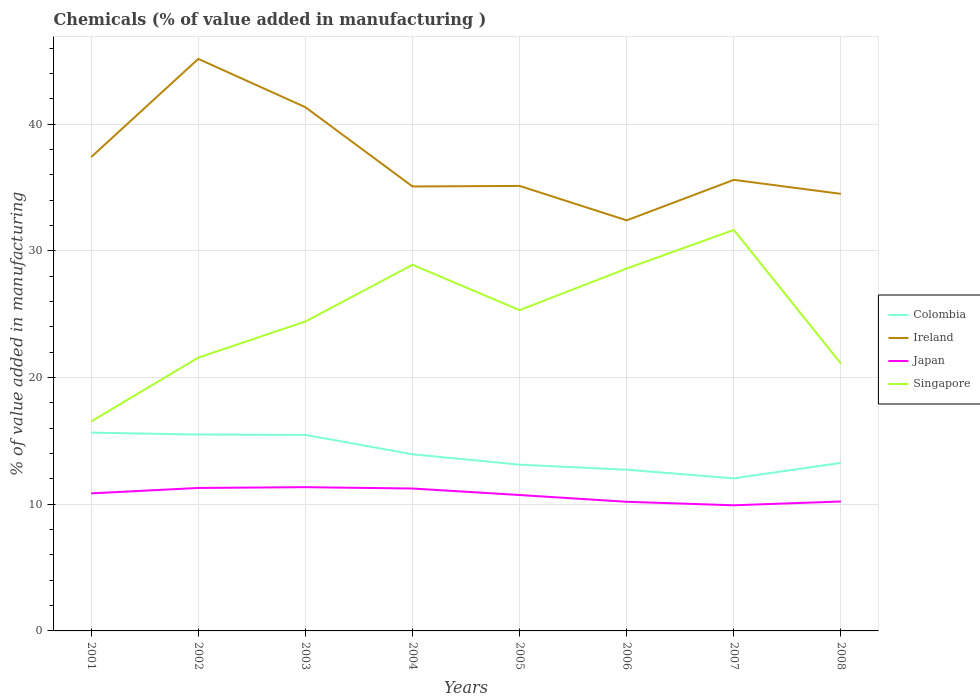Across all years, what is the maximum value added in manufacturing chemicals in Singapore?
Your response must be concise. 16.53. What is the total value added in manufacturing chemicals in Colombia in the graph?
Keep it short and to the point. 2.21. What is the difference between the highest and the second highest value added in manufacturing chemicals in Colombia?
Provide a short and direct response. 3.61. What is the difference between the highest and the lowest value added in manufacturing chemicals in Singapore?
Ensure brevity in your answer.  4. Is the value added in manufacturing chemicals in Singapore strictly greater than the value added in manufacturing chemicals in Japan over the years?
Your answer should be compact. No. How many years are there in the graph?
Your answer should be compact. 8. What is the difference between two consecutive major ticks on the Y-axis?
Your answer should be very brief. 10. Does the graph contain grids?
Offer a terse response. Yes. How many legend labels are there?
Your response must be concise. 4. What is the title of the graph?
Your answer should be compact. Chemicals (% of value added in manufacturing ). Does "Sierra Leone" appear as one of the legend labels in the graph?
Give a very brief answer. No. What is the label or title of the X-axis?
Provide a short and direct response. Years. What is the label or title of the Y-axis?
Provide a short and direct response. % of value added in manufacturing. What is the % of value added in manufacturing in Colombia in 2001?
Keep it short and to the point. 15.65. What is the % of value added in manufacturing in Ireland in 2001?
Provide a short and direct response. 37.4. What is the % of value added in manufacturing in Japan in 2001?
Your answer should be compact. 10.86. What is the % of value added in manufacturing in Singapore in 2001?
Make the answer very short. 16.53. What is the % of value added in manufacturing in Colombia in 2002?
Keep it short and to the point. 15.5. What is the % of value added in manufacturing in Ireland in 2002?
Your answer should be compact. 45.14. What is the % of value added in manufacturing in Japan in 2002?
Your response must be concise. 11.28. What is the % of value added in manufacturing in Singapore in 2002?
Give a very brief answer. 21.57. What is the % of value added in manufacturing in Colombia in 2003?
Offer a terse response. 15.47. What is the % of value added in manufacturing of Ireland in 2003?
Your answer should be very brief. 41.33. What is the % of value added in manufacturing of Japan in 2003?
Keep it short and to the point. 11.34. What is the % of value added in manufacturing in Singapore in 2003?
Your response must be concise. 24.42. What is the % of value added in manufacturing in Colombia in 2004?
Provide a succinct answer. 13.94. What is the % of value added in manufacturing in Ireland in 2004?
Your response must be concise. 35.08. What is the % of value added in manufacturing in Japan in 2004?
Offer a very short reply. 11.24. What is the % of value added in manufacturing in Singapore in 2004?
Your response must be concise. 28.9. What is the % of value added in manufacturing of Colombia in 2005?
Keep it short and to the point. 13.12. What is the % of value added in manufacturing of Ireland in 2005?
Provide a short and direct response. 35.12. What is the % of value added in manufacturing of Japan in 2005?
Provide a succinct answer. 10.73. What is the % of value added in manufacturing of Singapore in 2005?
Keep it short and to the point. 25.32. What is the % of value added in manufacturing in Colombia in 2006?
Your answer should be compact. 12.72. What is the % of value added in manufacturing of Ireland in 2006?
Keep it short and to the point. 32.4. What is the % of value added in manufacturing in Japan in 2006?
Offer a terse response. 10.19. What is the % of value added in manufacturing in Singapore in 2006?
Your answer should be compact. 28.6. What is the % of value added in manufacturing in Colombia in 2007?
Give a very brief answer. 12.04. What is the % of value added in manufacturing of Ireland in 2007?
Offer a terse response. 35.6. What is the % of value added in manufacturing of Japan in 2007?
Make the answer very short. 9.92. What is the % of value added in manufacturing in Singapore in 2007?
Provide a succinct answer. 31.65. What is the % of value added in manufacturing in Colombia in 2008?
Offer a very short reply. 13.26. What is the % of value added in manufacturing of Ireland in 2008?
Ensure brevity in your answer.  34.49. What is the % of value added in manufacturing of Japan in 2008?
Offer a very short reply. 10.21. What is the % of value added in manufacturing in Singapore in 2008?
Provide a short and direct response. 21.1. Across all years, what is the maximum % of value added in manufacturing of Colombia?
Ensure brevity in your answer.  15.65. Across all years, what is the maximum % of value added in manufacturing of Ireland?
Give a very brief answer. 45.14. Across all years, what is the maximum % of value added in manufacturing in Japan?
Give a very brief answer. 11.34. Across all years, what is the maximum % of value added in manufacturing of Singapore?
Make the answer very short. 31.65. Across all years, what is the minimum % of value added in manufacturing in Colombia?
Offer a terse response. 12.04. Across all years, what is the minimum % of value added in manufacturing in Ireland?
Give a very brief answer. 32.4. Across all years, what is the minimum % of value added in manufacturing of Japan?
Provide a short and direct response. 9.92. Across all years, what is the minimum % of value added in manufacturing of Singapore?
Give a very brief answer. 16.53. What is the total % of value added in manufacturing in Colombia in the graph?
Offer a terse response. 111.7. What is the total % of value added in manufacturing in Ireland in the graph?
Your answer should be compact. 296.56. What is the total % of value added in manufacturing in Japan in the graph?
Keep it short and to the point. 85.77. What is the total % of value added in manufacturing in Singapore in the graph?
Your answer should be very brief. 198.08. What is the difference between the % of value added in manufacturing of Colombia in 2001 and that in 2002?
Ensure brevity in your answer.  0.15. What is the difference between the % of value added in manufacturing in Ireland in 2001 and that in 2002?
Offer a terse response. -7.75. What is the difference between the % of value added in manufacturing of Japan in 2001 and that in 2002?
Offer a terse response. -0.43. What is the difference between the % of value added in manufacturing in Singapore in 2001 and that in 2002?
Make the answer very short. -5.04. What is the difference between the % of value added in manufacturing of Colombia in 2001 and that in 2003?
Keep it short and to the point. 0.18. What is the difference between the % of value added in manufacturing of Ireland in 2001 and that in 2003?
Offer a terse response. -3.93. What is the difference between the % of value added in manufacturing of Japan in 2001 and that in 2003?
Your response must be concise. -0.49. What is the difference between the % of value added in manufacturing of Singapore in 2001 and that in 2003?
Ensure brevity in your answer.  -7.88. What is the difference between the % of value added in manufacturing of Colombia in 2001 and that in 2004?
Offer a very short reply. 1.71. What is the difference between the % of value added in manufacturing in Ireland in 2001 and that in 2004?
Offer a very short reply. 2.32. What is the difference between the % of value added in manufacturing of Japan in 2001 and that in 2004?
Provide a short and direct response. -0.38. What is the difference between the % of value added in manufacturing of Singapore in 2001 and that in 2004?
Give a very brief answer. -12.36. What is the difference between the % of value added in manufacturing in Colombia in 2001 and that in 2005?
Keep it short and to the point. 2.53. What is the difference between the % of value added in manufacturing of Ireland in 2001 and that in 2005?
Keep it short and to the point. 2.28. What is the difference between the % of value added in manufacturing in Japan in 2001 and that in 2005?
Keep it short and to the point. 0.13. What is the difference between the % of value added in manufacturing of Singapore in 2001 and that in 2005?
Offer a terse response. -8.78. What is the difference between the % of value added in manufacturing in Colombia in 2001 and that in 2006?
Make the answer very short. 2.93. What is the difference between the % of value added in manufacturing in Ireland in 2001 and that in 2006?
Your answer should be very brief. 5. What is the difference between the % of value added in manufacturing of Japan in 2001 and that in 2006?
Your answer should be very brief. 0.66. What is the difference between the % of value added in manufacturing of Singapore in 2001 and that in 2006?
Offer a very short reply. -12.07. What is the difference between the % of value added in manufacturing in Colombia in 2001 and that in 2007?
Offer a terse response. 3.61. What is the difference between the % of value added in manufacturing in Ireland in 2001 and that in 2007?
Your answer should be compact. 1.8. What is the difference between the % of value added in manufacturing of Japan in 2001 and that in 2007?
Make the answer very short. 0.94. What is the difference between the % of value added in manufacturing in Singapore in 2001 and that in 2007?
Offer a terse response. -15.11. What is the difference between the % of value added in manufacturing in Colombia in 2001 and that in 2008?
Your answer should be compact. 2.39. What is the difference between the % of value added in manufacturing in Ireland in 2001 and that in 2008?
Give a very brief answer. 2.9. What is the difference between the % of value added in manufacturing of Japan in 2001 and that in 2008?
Provide a short and direct response. 0.64. What is the difference between the % of value added in manufacturing in Singapore in 2001 and that in 2008?
Your answer should be compact. -4.57. What is the difference between the % of value added in manufacturing of Colombia in 2002 and that in 2003?
Ensure brevity in your answer.  0.03. What is the difference between the % of value added in manufacturing in Ireland in 2002 and that in 2003?
Offer a very short reply. 3.81. What is the difference between the % of value added in manufacturing in Japan in 2002 and that in 2003?
Your answer should be very brief. -0.06. What is the difference between the % of value added in manufacturing of Singapore in 2002 and that in 2003?
Your answer should be compact. -2.85. What is the difference between the % of value added in manufacturing in Colombia in 2002 and that in 2004?
Your response must be concise. 1.56. What is the difference between the % of value added in manufacturing of Ireland in 2002 and that in 2004?
Keep it short and to the point. 10.07. What is the difference between the % of value added in manufacturing in Japan in 2002 and that in 2004?
Your answer should be compact. 0.04. What is the difference between the % of value added in manufacturing in Singapore in 2002 and that in 2004?
Give a very brief answer. -7.33. What is the difference between the % of value added in manufacturing of Colombia in 2002 and that in 2005?
Give a very brief answer. 2.38. What is the difference between the % of value added in manufacturing in Ireland in 2002 and that in 2005?
Your answer should be compact. 10.03. What is the difference between the % of value added in manufacturing of Japan in 2002 and that in 2005?
Make the answer very short. 0.56. What is the difference between the % of value added in manufacturing in Singapore in 2002 and that in 2005?
Your response must be concise. -3.75. What is the difference between the % of value added in manufacturing of Colombia in 2002 and that in 2006?
Give a very brief answer. 2.78. What is the difference between the % of value added in manufacturing of Ireland in 2002 and that in 2006?
Ensure brevity in your answer.  12.74. What is the difference between the % of value added in manufacturing of Japan in 2002 and that in 2006?
Provide a succinct answer. 1.09. What is the difference between the % of value added in manufacturing in Singapore in 2002 and that in 2006?
Keep it short and to the point. -7.03. What is the difference between the % of value added in manufacturing of Colombia in 2002 and that in 2007?
Provide a succinct answer. 3.46. What is the difference between the % of value added in manufacturing of Ireland in 2002 and that in 2007?
Provide a succinct answer. 9.55. What is the difference between the % of value added in manufacturing in Japan in 2002 and that in 2007?
Offer a very short reply. 1.37. What is the difference between the % of value added in manufacturing of Singapore in 2002 and that in 2007?
Your answer should be very brief. -10.08. What is the difference between the % of value added in manufacturing of Colombia in 2002 and that in 2008?
Ensure brevity in your answer.  2.24. What is the difference between the % of value added in manufacturing of Ireland in 2002 and that in 2008?
Keep it short and to the point. 10.65. What is the difference between the % of value added in manufacturing of Japan in 2002 and that in 2008?
Offer a very short reply. 1.07. What is the difference between the % of value added in manufacturing in Singapore in 2002 and that in 2008?
Your answer should be compact. 0.47. What is the difference between the % of value added in manufacturing of Colombia in 2003 and that in 2004?
Provide a short and direct response. 1.53. What is the difference between the % of value added in manufacturing of Ireland in 2003 and that in 2004?
Make the answer very short. 6.25. What is the difference between the % of value added in manufacturing in Japan in 2003 and that in 2004?
Your answer should be compact. 0.11. What is the difference between the % of value added in manufacturing of Singapore in 2003 and that in 2004?
Ensure brevity in your answer.  -4.48. What is the difference between the % of value added in manufacturing of Colombia in 2003 and that in 2005?
Ensure brevity in your answer.  2.35. What is the difference between the % of value added in manufacturing in Ireland in 2003 and that in 2005?
Your answer should be compact. 6.21. What is the difference between the % of value added in manufacturing of Japan in 2003 and that in 2005?
Offer a very short reply. 0.62. What is the difference between the % of value added in manufacturing of Singapore in 2003 and that in 2005?
Give a very brief answer. -0.9. What is the difference between the % of value added in manufacturing in Colombia in 2003 and that in 2006?
Offer a very short reply. 2.75. What is the difference between the % of value added in manufacturing of Ireland in 2003 and that in 2006?
Provide a short and direct response. 8.93. What is the difference between the % of value added in manufacturing in Japan in 2003 and that in 2006?
Provide a short and direct response. 1.15. What is the difference between the % of value added in manufacturing in Singapore in 2003 and that in 2006?
Provide a succinct answer. -4.18. What is the difference between the % of value added in manufacturing in Colombia in 2003 and that in 2007?
Provide a succinct answer. 3.43. What is the difference between the % of value added in manufacturing of Ireland in 2003 and that in 2007?
Provide a succinct answer. 5.73. What is the difference between the % of value added in manufacturing of Japan in 2003 and that in 2007?
Make the answer very short. 1.43. What is the difference between the % of value added in manufacturing in Singapore in 2003 and that in 2007?
Give a very brief answer. -7.23. What is the difference between the % of value added in manufacturing of Colombia in 2003 and that in 2008?
Give a very brief answer. 2.21. What is the difference between the % of value added in manufacturing of Ireland in 2003 and that in 2008?
Offer a terse response. 6.84. What is the difference between the % of value added in manufacturing of Japan in 2003 and that in 2008?
Your answer should be compact. 1.13. What is the difference between the % of value added in manufacturing of Singapore in 2003 and that in 2008?
Offer a terse response. 3.32. What is the difference between the % of value added in manufacturing of Colombia in 2004 and that in 2005?
Your answer should be very brief. 0.82. What is the difference between the % of value added in manufacturing in Ireland in 2004 and that in 2005?
Give a very brief answer. -0.04. What is the difference between the % of value added in manufacturing of Japan in 2004 and that in 2005?
Your response must be concise. 0.51. What is the difference between the % of value added in manufacturing in Singapore in 2004 and that in 2005?
Provide a short and direct response. 3.58. What is the difference between the % of value added in manufacturing in Colombia in 2004 and that in 2006?
Your response must be concise. 1.22. What is the difference between the % of value added in manufacturing of Ireland in 2004 and that in 2006?
Make the answer very short. 2.67. What is the difference between the % of value added in manufacturing of Japan in 2004 and that in 2006?
Your answer should be compact. 1.05. What is the difference between the % of value added in manufacturing in Singapore in 2004 and that in 2006?
Your answer should be compact. 0.3. What is the difference between the % of value added in manufacturing in Colombia in 2004 and that in 2007?
Your response must be concise. 1.9. What is the difference between the % of value added in manufacturing of Ireland in 2004 and that in 2007?
Your response must be concise. -0.52. What is the difference between the % of value added in manufacturing in Japan in 2004 and that in 2007?
Make the answer very short. 1.32. What is the difference between the % of value added in manufacturing of Singapore in 2004 and that in 2007?
Keep it short and to the point. -2.75. What is the difference between the % of value added in manufacturing in Colombia in 2004 and that in 2008?
Give a very brief answer. 0.68. What is the difference between the % of value added in manufacturing in Ireland in 2004 and that in 2008?
Offer a terse response. 0.58. What is the difference between the % of value added in manufacturing of Japan in 2004 and that in 2008?
Your response must be concise. 1.02. What is the difference between the % of value added in manufacturing of Singapore in 2004 and that in 2008?
Offer a terse response. 7.8. What is the difference between the % of value added in manufacturing in Colombia in 2005 and that in 2006?
Provide a short and direct response. 0.4. What is the difference between the % of value added in manufacturing in Ireland in 2005 and that in 2006?
Ensure brevity in your answer.  2.72. What is the difference between the % of value added in manufacturing of Japan in 2005 and that in 2006?
Ensure brevity in your answer.  0.53. What is the difference between the % of value added in manufacturing of Singapore in 2005 and that in 2006?
Offer a terse response. -3.29. What is the difference between the % of value added in manufacturing in Colombia in 2005 and that in 2007?
Provide a short and direct response. 1.08. What is the difference between the % of value added in manufacturing in Ireland in 2005 and that in 2007?
Your answer should be compact. -0.48. What is the difference between the % of value added in manufacturing in Japan in 2005 and that in 2007?
Offer a very short reply. 0.81. What is the difference between the % of value added in manufacturing of Singapore in 2005 and that in 2007?
Keep it short and to the point. -6.33. What is the difference between the % of value added in manufacturing of Colombia in 2005 and that in 2008?
Provide a short and direct response. -0.14. What is the difference between the % of value added in manufacturing of Ireland in 2005 and that in 2008?
Ensure brevity in your answer.  0.63. What is the difference between the % of value added in manufacturing in Japan in 2005 and that in 2008?
Make the answer very short. 0.51. What is the difference between the % of value added in manufacturing of Singapore in 2005 and that in 2008?
Your response must be concise. 4.22. What is the difference between the % of value added in manufacturing of Colombia in 2006 and that in 2007?
Offer a terse response. 0.68. What is the difference between the % of value added in manufacturing of Ireland in 2006 and that in 2007?
Provide a succinct answer. -3.2. What is the difference between the % of value added in manufacturing in Japan in 2006 and that in 2007?
Provide a short and direct response. 0.28. What is the difference between the % of value added in manufacturing of Singapore in 2006 and that in 2007?
Offer a very short reply. -3.05. What is the difference between the % of value added in manufacturing in Colombia in 2006 and that in 2008?
Your response must be concise. -0.54. What is the difference between the % of value added in manufacturing of Ireland in 2006 and that in 2008?
Provide a short and direct response. -2.09. What is the difference between the % of value added in manufacturing of Japan in 2006 and that in 2008?
Make the answer very short. -0.02. What is the difference between the % of value added in manufacturing of Singapore in 2006 and that in 2008?
Provide a succinct answer. 7.5. What is the difference between the % of value added in manufacturing in Colombia in 2007 and that in 2008?
Your answer should be very brief. -1.22. What is the difference between the % of value added in manufacturing of Ireland in 2007 and that in 2008?
Ensure brevity in your answer.  1.11. What is the difference between the % of value added in manufacturing of Japan in 2007 and that in 2008?
Provide a short and direct response. -0.3. What is the difference between the % of value added in manufacturing in Singapore in 2007 and that in 2008?
Provide a succinct answer. 10.55. What is the difference between the % of value added in manufacturing of Colombia in 2001 and the % of value added in manufacturing of Ireland in 2002?
Keep it short and to the point. -29.5. What is the difference between the % of value added in manufacturing in Colombia in 2001 and the % of value added in manufacturing in Japan in 2002?
Your response must be concise. 4.37. What is the difference between the % of value added in manufacturing in Colombia in 2001 and the % of value added in manufacturing in Singapore in 2002?
Your answer should be compact. -5.92. What is the difference between the % of value added in manufacturing in Ireland in 2001 and the % of value added in manufacturing in Japan in 2002?
Your answer should be compact. 26.12. What is the difference between the % of value added in manufacturing of Ireland in 2001 and the % of value added in manufacturing of Singapore in 2002?
Your answer should be compact. 15.83. What is the difference between the % of value added in manufacturing in Japan in 2001 and the % of value added in manufacturing in Singapore in 2002?
Keep it short and to the point. -10.71. What is the difference between the % of value added in manufacturing of Colombia in 2001 and the % of value added in manufacturing of Ireland in 2003?
Provide a succinct answer. -25.68. What is the difference between the % of value added in manufacturing in Colombia in 2001 and the % of value added in manufacturing in Japan in 2003?
Provide a succinct answer. 4.3. What is the difference between the % of value added in manufacturing in Colombia in 2001 and the % of value added in manufacturing in Singapore in 2003?
Provide a short and direct response. -8.77. What is the difference between the % of value added in manufacturing of Ireland in 2001 and the % of value added in manufacturing of Japan in 2003?
Offer a very short reply. 26.05. What is the difference between the % of value added in manufacturing in Ireland in 2001 and the % of value added in manufacturing in Singapore in 2003?
Ensure brevity in your answer.  12.98. What is the difference between the % of value added in manufacturing of Japan in 2001 and the % of value added in manufacturing of Singapore in 2003?
Offer a very short reply. -13.56. What is the difference between the % of value added in manufacturing in Colombia in 2001 and the % of value added in manufacturing in Ireland in 2004?
Offer a very short reply. -19.43. What is the difference between the % of value added in manufacturing of Colombia in 2001 and the % of value added in manufacturing of Japan in 2004?
Offer a very short reply. 4.41. What is the difference between the % of value added in manufacturing in Colombia in 2001 and the % of value added in manufacturing in Singapore in 2004?
Offer a terse response. -13.25. What is the difference between the % of value added in manufacturing in Ireland in 2001 and the % of value added in manufacturing in Japan in 2004?
Offer a terse response. 26.16. What is the difference between the % of value added in manufacturing of Ireland in 2001 and the % of value added in manufacturing of Singapore in 2004?
Keep it short and to the point. 8.5. What is the difference between the % of value added in manufacturing of Japan in 2001 and the % of value added in manufacturing of Singapore in 2004?
Provide a short and direct response. -18.04. What is the difference between the % of value added in manufacturing of Colombia in 2001 and the % of value added in manufacturing of Ireland in 2005?
Keep it short and to the point. -19.47. What is the difference between the % of value added in manufacturing of Colombia in 2001 and the % of value added in manufacturing of Japan in 2005?
Your answer should be very brief. 4.92. What is the difference between the % of value added in manufacturing in Colombia in 2001 and the % of value added in manufacturing in Singapore in 2005?
Your response must be concise. -9.67. What is the difference between the % of value added in manufacturing of Ireland in 2001 and the % of value added in manufacturing of Japan in 2005?
Make the answer very short. 26.67. What is the difference between the % of value added in manufacturing of Ireland in 2001 and the % of value added in manufacturing of Singapore in 2005?
Your answer should be very brief. 12.08. What is the difference between the % of value added in manufacturing of Japan in 2001 and the % of value added in manufacturing of Singapore in 2005?
Your answer should be very brief. -14.46. What is the difference between the % of value added in manufacturing of Colombia in 2001 and the % of value added in manufacturing of Ireland in 2006?
Offer a terse response. -16.75. What is the difference between the % of value added in manufacturing of Colombia in 2001 and the % of value added in manufacturing of Japan in 2006?
Your answer should be compact. 5.46. What is the difference between the % of value added in manufacturing in Colombia in 2001 and the % of value added in manufacturing in Singapore in 2006?
Ensure brevity in your answer.  -12.95. What is the difference between the % of value added in manufacturing of Ireland in 2001 and the % of value added in manufacturing of Japan in 2006?
Your answer should be very brief. 27.21. What is the difference between the % of value added in manufacturing in Ireland in 2001 and the % of value added in manufacturing in Singapore in 2006?
Your answer should be very brief. 8.8. What is the difference between the % of value added in manufacturing of Japan in 2001 and the % of value added in manufacturing of Singapore in 2006?
Provide a short and direct response. -17.74. What is the difference between the % of value added in manufacturing of Colombia in 2001 and the % of value added in manufacturing of Ireland in 2007?
Give a very brief answer. -19.95. What is the difference between the % of value added in manufacturing of Colombia in 2001 and the % of value added in manufacturing of Japan in 2007?
Your answer should be very brief. 5.73. What is the difference between the % of value added in manufacturing of Colombia in 2001 and the % of value added in manufacturing of Singapore in 2007?
Provide a succinct answer. -16. What is the difference between the % of value added in manufacturing of Ireland in 2001 and the % of value added in manufacturing of Japan in 2007?
Provide a succinct answer. 27.48. What is the difference between the % of value added in manufacturing in Ireland in 2001 and the % of value added in manufacturing in Singapore in 2007?
Your answer should be compact. 5.75. What is the difference between the % of value added in manufacturing of Japan in 2001 and the % of value added in manufacturing of Singapore in 2007?
Your response must be concise. -20.79. What is the difference between the % of value added in manufacturing of Colombia in 2001 and the % of value added in manufacturing of Ireland in 2008?
Give a very brief answer. -18.85. What is the difference between the % of value added in manufacturing in Colombia in 2001 and the % of value added in manufacturing in Japan in 2008?
Offer a very short reply. 5.43. What is the difference between the % of value added in manufacturing in Colombia in 2001 and the % of value added in manufacturing in Singapore in 2008?
Provide a short and direct response. -5.45. What is the difference between the % of value added in manufacturing of Ireland in 2001 and the % of value added in manufacturing of Japan in 2008?
Your answer should be very brief. 27.18. What is the difference between the % of value added in manufacturing in Ireland in 2001 and the % of value added in manufacturing in Singapore in 2008?
Your answer should be very brief. 16.3. What is the difference between the % of value added in manufacturing of Japan in 2001 and the % of value added in manufacturing of Singapore in 2008?
Your response must be concise. -10.24. What is the difference between the % of value added in manufacturing in Colombia in 2002 and the % of value added in manufacturing in Ireland in 2003?
Ensure brevity in your answer.  -25.83. What is the difference between the % of value added in manufacturing of Colombia in 2002 and the % of value added in manufacturing of Japan in 2003?
Make the answer very short. 4.15. What is the difference between the % of value added in manufacturing in Colombia in 2002 and the % of value added in manufacturing in Singapore in 2003?
Give a very brief answer. -8.92. What is the difference between the % of value added in manufacturing in Ireland in 2002 and the % of value added in manufacturing in Japan in 2003?
Make the answer very short. 33.8. What is the difference between the % of value added in manufacturing of Ireland in 2002 and the % of value added in manufacturing of Singapore in 2003?
Keep it short and to the point. 20.73. What is the difference between the % of value added in manufacturing of Japan in 2002 and the % of value added in manufacturing of Singapore in 2003?
Offer a terse response. -13.13. What is the difference between the % of value added in manufacturing in Colombia in 2002 and the % of value added in manufacturing in Ireland in 2004?
Keep it short and to the point. -19.58. What is the difference between the % of value added in manufacturing in Colombia in 2002 and the % of value added in manufacturing in Japan in 2004?
Make the answer very short. 4.26. What is the difference between the % of value added in manufacturing in Colombia in 2002 and the % of value added in manufacturing in Singapore in 2004?
Your answer should be compact. -13.4. What is the difference between the % of value added in manufacturing of Ireland in 2002 and the % of value added in manufacturing of Japan in 2004?
Provide a succinct answer. 33.91. What is the difference between the % of value added in manufacturing of Ireland in 2002 and the % of value added in manufacturing of Singapore in 2004?
Offer a very short reply. 16.25. What is the difference between the % of value added in manufacturing of Japan in 2002 and the % of value added in manufacturing of Singapore in 2004?
Provide a succinct answer. -17.61. What is the difference between the % of value added in manufacturing of Colombia in 2002 and the % of value added in manufacturing of Ireland in 2005?
Make the answer very short. -19.62. What is the difference between the % of value added in manufacturing of Colombia in 2002 and the % of value added in manufacturing of Japan in 2005?
Your answer should be compact. 4.77. What is the difference between the % of value added in manufacturing in Colombia in 2002 and the % of value added in manufacturing in Singapore in 2005?
Provide a short and direct response. -9.82. What is the difference between the % of value added in manufacturing in Ireland in 2002 and the % of value added in manufacturing in Japan in 2005?
Your answer should be very brief. 34.42. What is the difference between the % of value added in manufacturing in Ireland in 2002 and the % of value added in manufacturing in Singapore in 2005?
Offer a very short reply. 19.83. What is the difference between the % of value added in manufacturing in Japan in 2002 and the % of value added in manufacturing in Singapore in 2005?
Provide a succinct answer. -14.03. What is the difference between the % of value added in manufacturing of Colombia in 2002 and the % of value added in manufacturing of Ireland in 2006?
Provide a succinct answer. -16.9. What is the difference between the % of value added in manufacturing in Colombia in 2002 and the % of value added in manufacturing in Japan in 2006?
Provide a succinct answer. 5.31. What is the difference between the % of value added in manufacturing in Colombia in 2002 and the % of value added in manufacturing in Singapore in 2006?
Offer a very short reply. -13.1. What is the difference between the % of value added in manufacturing of Ireland in 2002 and the % of value added in manufacturing of Japan in 2006?
Offer a very short reply. 34.95. What is the difference between the % of value added in manufacturing of Ireland in 2002 and the % of value added in manufacturing of Singapore in 2006?
Provide a succinct answer. 16.54. What is the difference between the % of value added in manufacturing in Japan in 2002 and the % of value added in manufacturing in Singapore in 2006?
Provide a short and direct response. -17.32. What is the difference between the % of value added in manufacturing of Colombia in 2002 and the % of value added in manufacturing of Ireland in 2007?
Your answer should be compact. -20.1. What is the difference between the % of value added in manufacturing of Colombia in 2002 and the % of value added in manufacturing of Japan in 2007?
Make the answer very short. 5.58. What is the difference between the % of value added in manufacturing in Colombia in 2002 and the % of value added in manufacturing in Singapore in 2007?
Offer a terse response. -16.15. What is the difference between the % of value added in manufacturing in Ireland in 2002 and the % of value added in manufacturing in Japan in 2007?
Keep it short and to the point. 35.23. What is the difference between the % of value added in manufacturing in Ireland in 2002 and the % of value added in manufacturing in Singapore in 2007?
Offer a terse response. 13.5. What is the difference between the % of value added in manufacturing in Japan in 2002 and the % of value added in manufacturing in Singapore in 2007?
Offer a very short reply. -20.36. What is the difference between the % of value added in manufacturing of Colombia in 2002 and the % of value added in manufacturing of Ireland in 2008?
Make the answer very short. -19. What is the difference between the % of value added in manufacturing in Colombia in 2002 and the % of value added in manufacturing in Japan in 2008?
Make the answer very short. 5.28. What is the difference between the % of value added in manufacturing in Colombia in 2002 and the % of value added in manufacturing in Singapore in 2008?
Provide a succinct answer. -5.6. What is the difference between the % of value added in manufacturing in Ireland in 2002 and the % of value added in manufacturing in Japan in 2008?
Provide a short and direct response. 34.93. What is the difference between the % of value added in manufacturing of Ireland in 2002 and the % of value added in manufacturing of Singapore in 2008?
Your answer should be compact. 24.04. What is the difference between the % of value added in manufacturing of Japan in 2002 and the % of value added in manufacturing of Singapore in 2008?
Your answer should be compact. -9.82. What is the difference between the % of value added in manufacturing in Colombia in 2003 and the % of value added in manufacturing in Ireland in 2004?
Keep it short and to the point. -19.61. What is the difference between the % of value added in manufacturing in Colombia in 2003 and the % of value added in manufacturing in Japan in 2004?
Offer a terse response. 4.23. What is the difference between the % of value added in manufacturing in Colombia in 2003 and the % of value added in manufacturing in Singapore in 2004?
Keep it short and to the point. -13.43. What is the difference between the % of value added in manufacturing of Ireland in 2003 and the % of value added in manufacturing of Japan in 2004?
Give a very brief answer. 30.09. What is the difference between the % of value added in manufacturing in Ireland in 2003 and the % of value added in manufacturing in Singapore in 2004?
Provide a short and direct response. 12.43. What is the difference between the % of value added in manufacturing in Japan in 2003 and the % of value added in manufacturing in Singapore in 2004?
Ensure brevity in your answer.  -17.55. What is the difference between the % of value added in manufacturing of Colombia in 2003 and the % of value added in manufacturing of Ireland in 2005?
Provide a short and direct response. -19.65. What is the difference between the % of value added in manufacturing in Colombia in 2003 and the % of value added in manufacturing in Japan in 2005?
Your answer should be very brief. 4.74. What is the difference between the % of value added in manufacturing in Colombia in 2003 and the % of value added in manufacturing in Singapore in 2005?
Your answer should be compact. -9.85. What is the difference between the % of value added in manufacturing in Ireland in 2003 and the % of value added in manufacturing in Japan in 2005?
Make the answer very short. 30.61. What is the difference between the % of value added in manufacturing in Ireland in 2003 and the % of value added in manufacturing in Singapore in 2005?
Offer a very short reply. 16.02. What is the difference between the % of value added in manufacturing of Japan in 2003 and the % of value added in manufacturing of Singapore in 2005?
Provide a short and direct response. -13.97. What is the difference between the % of value added in manufacturing in Colombia in 2003 and the % of value added in manufacturing in Ireland in 2006?
Ensure brevity in your answer.  -16.93. What is the difference between the % of value added in manufacturing in Colombia in 2003 and the % of value added in manufacturing in Japan in 2006?
Your answer should be very brief. 5.28. What is the difference between the % of value added in manufacturing in Colombia in 2003 and the % of value added in manufacturing in Singapore in 2006?
Your response must be concise. -13.13. What is the difference between the % of value added in manufacturing of Ireland in 2003 and the % of value added in manufacturing of Japan in 2006?
Keep it short and to the point. 31.14. What is the difference between the % of value added in manufacturing in Ireland in 2003 and the % of value added in manufacturing in Singapore in 2006?
Your answer should be compact. 12.73. What is the difference between the % of value added in manufacturing of Japan in 2003 and the % of value added in manufacturing of Singapore in 2006?
Keep it short and to the point. -17.26. What is the difference between the % of value added in manufacturing in Colombia in 2003 and the % of value added in manufacturing in Ireland in 2007?
Your answer should be compact. -20.13. What is the difference between the % of value added in manufacturing in Colombia in 2003 and the % of value added in manufacturing in Japan in 2007?
Provide a short and direct response. 5.55. What is the difference between the % of value added in manufacturing of Colombia in 2003 and the % of value added in manufacturing of Singapore in 2007?
Provide a succinct answer. -16.18. What is the difference between the % of value added in manufacturing of Ireland in 2003 and the % of value added in manufacturing of Japan in 2007?
Your answer should be very brief. 31.42. What is the difference between the % of value added in manufacturing of Ireland in 2003 and the % of value added in manufacturing of Singapore in 2007?
Provide a succinct answer. 9.68. What is the difference between the % of value added in manufacturing of Japan in 2003 and the % of value added in manufacturing of Singapore in 2007?
Give a very brief answer. -20.3. What is the difference between the % of value added in manufacturing in Colombia in 2003 and the % of value added in manufacturing in Ireland in 2008?
Offer a terse response. -19.02. What is the difference between the % of value added in manufacturing of Colombia in 2003 and the % of value added in manufacturing of Japan in 2008?
Provide a succinct answer. 5.26. What is the difference between the % of value added in manufacturing in Colombia in 2003 and the % of value added in manufacturing in Singapore in 2008?
Give a very brief answer. -5.63. What is the difference between the % of value added in manufacturing of Ireland in 2003 and the % of value added in manufacturing of Japan in 2008?
Provide a short and direct response. 31.12. What is the difference between the % of value added in manufacturing in Ireland in 2003 and the % of value added in manufacturing in Singapore in 2008?
Keep it short and to the point. 20.23. What is the difference between the % of value added in manufacturing in Japan in 2003 and the % of value added in manufacturing in Singapore in 2008?
Your answer should be very brief. -9.76. What is the difference between the % of value added in manufacturing of Colombia in 2004 and the % of value added in manufacturing of Ireland in 2005?
Offer a terse response. -21.18. What is the difference between the % of value added in manufacturing in Colombia in 2004 and the % of value added in manufacturing in Japan in 2005?
Offer a very short reply. 3.22. What is the difference between the % of value added in manufacturing in Colombia in 2004 and the % of value added in manufacturing in Singapore in 2005?
Your response must be concise. -11.37. What is the difference between the % of value added in manufacturing of Ireland in 2004 and the % of value added in manufacturing of Japan in 2005?
Offer a terse response. 24.35. What is the difference between the % of value added in manufacturing of Ireland in 2004 and the % of value added in manufacturing of Singapore in 2005?
Make the answer very short. 9.76. What is the difference between the % of value added in manufacturing of Japan in 2004 and the % of value added in manufacturing of Singapore in 2005?
Your answer should be compact. -14.08. What is the difference between the % of value added in manufacturing in Colombia in 2004 and the % of value added in manufacturing in Ireland in 2006?
Provide a short and direct response. -18.46. What is the difference between the % of value added in manufacturing in Colombia in 2004 and the % of value added in manufacturing in Japan in 2006?
Give a very brief answer. 3.75. What is the difference between the % of value added in manufacturing in Colombia in 2004 and the % of value added in manufacturing in Singapore in 2006?
Make the answer very short. -14.66. What is the difference between the % of value added in manufacturing in Ireland in 2004 and the % of value added in manufacturing in Japan in 2006?
Your response must be concise. 24.88. What is the difference between the % of value added in manufacturing of Ireland in 2004 and the % of value added in manufacturing of Singapore in 2006?
Provide a short and direct response. 6.48. What is the difference between the % of value added in manufacturing in Japan in 2004 and the % of value added in manufacturing in Singapore in 2006?
Make the answer very short. -17.36. What is the difference between the % of value added in manufacturing in Colombia in 2004 and the % of value added in manufacturing in Ireland in 2007?
Your answer should be very brief. -21.66. What is the difference between the % of value added in manufacturing of Colombia in 2004 and the % of value added in manufacturing of Japan in 2007?
Give a very brief answer. 4.03. What is the difference between the % of value added in manufacturing in Colombia in 2004 and the % of value added in manufacturing in Singapore in 2007?
Make the answer very short. -17.71. What is the difference between the % of value added in manufacturing in Ireland in 2004 and the % of value added in manufacturing in Japan in 2007?
Your answer should be very brief. 25.16. What is the difference between the % of value added in manufacturing in Ireland in 2004 and the % of value added in manufacturing in Singapore in 2007?
Keep it short and to the point. 3.43. What is the difference between the % of value added in manufacturing of Japan in 2004 and the % of value added in manufacturing of Singapore in 2007?
Your response must be concise. -20.41. What is the difference between the % of value added in manufacturing in Colombia in 2004 and the % of value added in manufacturing in Ireland in 2008?
Your response must be concise. -20.55. What is the difference between the % of value added in manufacturing in Colombia in 2004 and the % of value added in manufacturing in Japan in 2008?
Offer a terse response. 3.73. What is the difference between the % of value added in manufacturing of Colombia in 2004 and the % of value added in manufacturing of Singapore in 2008?
Provide a succinct answer. -7.16. What is the difference between the % of value added in manufacturing in Ireland in 2004 and the % of value added in manufacturing in Japan in 2008?
Provide a succinct answer. 24.86. What is the difference between the % of value added in manufacturing of Ireland in 2004 and the % of value added in manufacturing of Singapore in 2008?
Keep it short and to the point. 13.98. What is the difference between the % of value added in manufacturing in Japan in 2004 and the % of value added in manufacturing in Singapore in 2008?
Offer a terse response. -9.86. What is the difference between the % of value added in manufacturing in Colombia in 2005 and the % of value added in manufacturing in Ireland in 2006?
Provide a short and direct response. -19.28. What is the difference between the % of value added in manufacturing of Colombia in 2005 and the % of value added in manufacturing of Japan in 2006?
Provide a short and direct response. 2.93. What is the difference between the % of value added in manufacturing in Colombia in 2005 and the % of value added in manufacturing in Singapore in 2006?
Your answer should be very brief. -15.48. What is the difference between the % of value added in manufacturing in Ireland in 2005 and the % of value added in manufacturing in Japan in 2006?
Provide a succinct answer. 24.93. What is the difference between the % of value added in manufacturing in Ireland in 2005 and the % of value added in manufacturing in Singapore in 2006?
Offer a terse response. 6.52. What is the difference between the % of value added in manufacturing in Japan in 2005 and the % of value added in manufacturing in Singapore in 2006?
Provide a succinct answer. -17.87. What is the difference between the % of value added in manufacturing of Colombia in 2005 and the % of value added in manufacturing of Ireland in 2007?
Ensure brevity in your answer.  -22.48. What is the difference between the % of value added in manufacturing of Colombia in 2005 and the % of value added in manufacturing of Japan in 2007?
Give a very brief answer. 3.21. What is the difference between the % of value added in manufacturing in Colombia in 2005 and the % of value added in manufacturing in Singapore in 2007?
Provide a succinct answer. -18.53. What is the difference between the % of value added in manufacturing of Ireland in 2005 and the % of value added in manufacturing of Japan in 2007?
Offer a terse response. 25.2. What is the difference between the % of value added in manufacturing in Ireland in 2005 and the % of value added in manufacturing in Singapore in 2007?
Your response must be concise. 3.47. What is the difference between the % of value added in manufacturing of Japan in 2005 and the % of value added in manufacturing of Singapore in 2007?
Offer a terse response. -20.92. What is the difference between the % of value added in manufacturing of Colombia in 2005 and the % of value added in manufacturing of Ireland in 2008?
Keep it short and to the point. -21.37. What is the difference between the % of value added in manufacturing of Colombia in 2005 and the % of value added in manufacturing of Japan in 2008?
Your answer should be compact. 2.91. What is the difference between the % of value added in manufacturing in Colombia in 2005 and the % of value added in manufacturing in Singapore in 2008?
Offer a terse response. -7.98. What is the difference between the % of value added in manufacturing of Ireland in 2005 and the % of value added in manufacturing of Japan in 2008?
Give a very brief answer. 24.91. What is the difference between the % of value added in manufacturing of Ireland in 2005 and the % of value added in manufacturing of Singapore in 2008?
Offer a terse response. 14.02. What is the difference between the % of value added in manufacturing of Japan in 2005 and the % of value added in manufacturing of Singapore in 2008?
Your response must be concise. -10.37. What is the difference between the % of value added in manufacturing of Colombia in 2006 and the % of value added in manufacturing of Ireland in 2007?
Offer a very short reply. -22.88. What is the difference between the % of value added in manufacturing in Colombia in 2006 and the % of value added in manufacturing in Japan in 2007?
Your response must be concise. 2.81. What is the difference between the % of value added in manufacturing in Colombia in 2006 and the % of value added in manufacturing in Singapore in 2007?
Your answer should be compact. -18.92. What is the difference between the % of value added in manufacturing of Ireland in 2006 and the % of value added in manufacturing of Japan in 2007?
Give a very brief answer. 22.49. What is the difference between the % of value added in manufacturing in Ireland in 2006 and the % of value added in manufacturing in Singapore in 2007?
Your response must be concise. 0.76. What is the difference between the % of value added in manufacturing of Japan in 2006 and the % of value added in manufacturing of Singapore in 2007?
Give a very brief answer. -21.45. What is the difference between the % of value added in manufacturing of Colombia in 2006 and the % of value added in manufacturing of Ireland in 2008?
Ensure brevity in your answer.  -21.77. What is the difference between the % of value added in manufacturing in Colombia in 2006 and the % of value added in manufacturing in Japan in 2008?
Offer a very short reply. 2.51. What is the difference between the % of value added in manufacturing of Colombia in 2006 and the % of value added in manufacturing of Singapore in 2008?
Provide a succinct answer. -8.38. What is the difference between the % of value added in manufacturing of Ireland in 2006 and the % of value added in manufacturing of Japan in 2008?
Offer a terse response. 22.19. What is the difference between the % of value added in manufacturing of Ireland in 2006 and the % of value added in manufacturing of Singapore in 2008?
Your response must be concise. 11.3. What is the difference between the % of value added in manufacturing of Japan in 2006 and the % of value added in manufacturing of Singapore in 2008?
Your answer should be compact. -10.91. What is the difference between the % of value added in manufacturing of Colombia in 2007 and the % of value added in manufacturing of Ireland in 2008?
Make the answer very short. -22.45. What is the difference between the % of value added in manufacturing in Colombia in 2007 and the % of value added in manufacturing in Japan in 2008?
Provide a short and direct response. 1.83. What is the difference between the % of value added in manufacturing in Colombia in 2007 and the % of value added in manufacturing in Singapore in 2008?
Your answer should be very brief. -9.06. What is the difference between the % of value added in manufacturing of Ireland in 2007 and the % of value added in manufacturing of Japan in 2008?
Provide a succinct answer. 25.39. What is the difference between the % of value added in manufacturing of Ireland in 2007 and the % of value added in manufacturing of Singapore in 2008?
Your answer should be very brief. 14.5. What is the difference between the % of value added in manufacturing in Japan in 2007 and the % of value added in manufacturing in Singapore in 2008?
Your response must be concise. -11.18. What is the average % of value added in manufacturing of Colombia per year?
Provide a short and direct response. 13.96. What is the average % of value added in manufacturing in Ireland per year?
Provide a short and direct response. 37.07. What is the average % of value added in manufacturing of Japan per year?
Your response must be concise. 10.72. What is the average % of value added in manufacturing in Singapore per year?
Your answer should be very brief. 24.76. In the year 2001, what is the difference between the % of value added in manufacturing of Colombia and % of value added in manufacturing of Ireland?
Provide a short and direct response. -21.75. In the year 2001, what is the difference between the % of value added in manufacturing in Colombia and % of value added in manufacturing in Japan?
Your response must be concise. 4.79. In the year 2001, what is the difference between the % of value added in manufacturing of Colombia and % of value added in manufacturing of Singapore?
Ensure brevity in your answer.  -0.88. In the year 2001, what is the difference between the % of value added in manufacturing in Ireland and % of value added in manufacturing in Japan?
Keep it short and to the point. 26.54. In the year 2001, what is the difference between the % of value added in manufacturing of Ireland and % of value added in manufacturing of Singapore?
Give a very brief answer. 20.87. In the year 2001, what is the difference between the % of value added in manufacturing of Japan and % of value added in manufacturing of Singapore?
Your answer should be very brief. -5.68. In the year 2002, what is the difference between the % of value added in manufacturing of Colombia and % of value added in manufacturing of Ireland?
Provide a succinct answer. -29.65. In the year 2002, what is the difference between the % of value added in manufacturing of Colombia and % of value added in manufacturing of Japan?
Your answer should be compact. 4.21. In the year 2002, what is the difference between the % of value added in manufacturing of Colombia and % of value added in manufacturing of Singapore?
Ensure brevity in your answer.  -6.07. In the year 2002, what is the difference between the % of value added in manufacturing in Ireland and % of value added in manufacturing in Japan?
Offer a very short reply. 33.86. In the year 2002, what is the difference between the % of value added in manufacturing of Ireland and % of value added in manufacturing of Singapore?
Give a very brief answer. 23.58. In the year 2002, what is the difference between the % of value added in manufacturing of Japan and % of value added in manufacturing of Singapore?
Offer a terse response. -10.29. In the year 2003, what is the difference between the % of value added in manufacturing in Colombia and % of value added in manufacturing in Ireland?
Keep it short and to the point. -25.86. In the year 2003, what is the difference between the % of value added in manufacturing in Colombia and % of value added in manufacturing in Japan?
Make the answer very short. 4.12. In the year 2003, what is the difference between the % of value added in manufacturing in Colombia and % of value added in manufacturing in Singapore?
Give a very brief answer. -8.95. In the year 2003, what is the difference between the % of value added in manufacturing of Ireland and % of value added in manufacturing of Japan?
Offer a very short reply. 29.99. In the year 2003, what is the difference between the % of value added in manufacturing in Ireland and % of value added in manufacturing in Singapore?
Give a very brief answer. 16.91. In the year 2003, what is the difference between the % of value added in manufacturing in Japan and % of value added in manufacturing in Singapore?
Keep it short and to the point. -13.07. In the year 2004, what is the difference between the % of value added in manufacturing of Colombia and % of value added in manufacturing of Ireland?
Provide a succinct answer. -21.14. In the year 2004, what is the difference between the % of value added in manufacturing in Colombia and % of value added in manufacturing in Japan?
Offer a terse response. 2.7. In the year 2004, what is the difference between the % of value added in manufacturing of Colombia and % of value added in manufacturing of Singapore?
Provide a short and direct response. -14.96. In the year 2004, what is the difference between the % of value added in manufacturing of Ireland and % of value added in manufacturing of Japan?
Offer a terse response. 23.84. In the year 2004, what is the difference between the % of value added in manufacturing in Ireland and % of value added in manufacturing in Singapore?
Provide a succinct answer. 6.18. In the year 2004, what is the difference between the % of value added in manufacturing in Japan and % of value added in manufacturing in Singapore?
Your answer should be very brief. -17.66. In the year 2005, what is the difference between the % of value added in manufacturing of Colombia and % of value added in manufacturing of Ireland?
Offer a terse response. -22. In the year 2005, what is the difference between the % of value added in manufacturing of Colombia and % of value added in manufacturing of Japan?
Offer a very short reply. 2.4. In the year 2005, what is the difference between the % of value added in manufacturing of Colombia and % of value added in manufacturing of Singapore?
Ensure brevity in your answer.  -12.19. In the year 2005, what is the difference between the % of value added in manufacturing in Ireland and % of value added in manufacturing in Japan?
Provide a succinct answer. 24.39. In the year 2005, what is the difference between the % of value added in manufacturing in Ireland and % of value added in manufacturing in Singapore?
Make the answer very short. 9.8. In the year 2005, what is the difference between the % of value added in manufacturing of Japan and % of value added in manufacturing of Singapore?
Ensure brevity in your answer.  -14.59. In the year 2006, what is the difference between the % of value added in manufacturing of Colombia and % of value added in manufacturing of Ireland?
Your answer should be very brief. -19.68. In the year 2006, what is the difference between the % of value added in manufacturing in Colombia and % of value added in manufacturing in Japan?
Make the answer very short. 2.53. In the year 2006, what is the difference between the % of value added in manufacturing in Colombia and % of value added in manufacturing in Singapore?
Your response must be concise. -15.88. In the year 2006, what is the difference between the % of value added in manufacturing in Ireland and % of value added in manufacturing in Japan?
Provide a succinct answer. 22.21. In the year 2006, what is the difference between the % of value added in manufacturing in Ireland and % of value added in manufacturing in Singapore?
Give a very brief answer. 3.8. In the year 2006, what is the difference between the % of value added in manufacturing in Japan and % of value added in manufacturing in Singapore?
Offer a terse response. -18.41. In the year 2007, what is the difference between the % of value added in manufacturing in Colombia and % of value added in manufacturing in Ireland?
Your response must be concise. -23.56. In the year 2007, what is the difference between the % of value added in manufacturing of Colombia and % of value added in manufacturing of Japan?
Provide a succinct answer. 2.13. In the year 2007, what is the difference between the % of value added in manufacturing of Colombia and % of value added in manufacturing of Singapore?
Make the answer very short. -19.6. In the year 2007, what is the difference between the % of value added in manufacturing in Ireland and % of value added in manufacturing in Japan?
Offer a very short reply. 25.68. In the year 2007, what is the difference between the % of value added in manufacturing in Ireland and % of value added in manufacturing in Singapore?
Your answer should be very brief. 3.95. In the year 2007, what is the difference between the % of value added in manufacturing in Japan and % of value added in manufacturing in Singapore?
Provide a succinct answer. -21.73. In the year 2008, what is the difference between the % of value added in manufacturing in Colombia and % of value added in manufacturing in Ireland?
Offer a very short reply. -21.23. In the year 2008, what is the difference between the % of value added in manufacturing of Colombia and % of value added in manufacturing of Japan?
Offer a very short reply. 3.05. In the year 2008, what is the difference between the % of value added in manufacturing of Colombia and % of value added in manufacturing of Singapore?
Make the answer very short. -7.84. In the year 2008, what is the difference between the % of value added in manufacturing in Ireland and % of value added in manufacturing in Japan?
Make the answer very short. 24.28. In the year 2008, what is the difference between the % of value added in manufacturing of Ireland and % of value added in manufacturing of Singapore?
Ensure brevity in your answer.  13.39. In the year 2008, what is the difference between the % of value added in manufacturing in Japan and % of value added in manufacturing in Singapore?
Provide a short and direct response. -10.89. What is the ratio of the % of value added in manufacturing in Colombia in 2001 to that in 2002?
Offer a very short reply. 1.01. What is the ratio of the % of value added in manufacturing in Ireland in 2001 to that in 2002?
Provide a short and direct response. 0.83. What is the ratio of the % of value added in manufacturing of Japan in 2001 to that in 2002?
Provide a short and direct response. 0.96. What is the ratio of the % of value added in manufacturing in Singapore in 2001 to that in 2002?
Ensure brevity in your answer.  0.77. What is the ratio of the % of value added in manufacturing in Colombia in 2001 to that in 2003?
Provide a short and direct response. 1.01. What is the ratio of the % of value added in manufacturing of Ireland in 2001 to that in 2003?
Give a very brief answer. 0.9. What is the ratio of the % of value added in manufacturing in Singapore in 2001 to that in 2003?
Make the answer very short. 0.68. What is the ratio of the % of value added in manufacturing of Colombia in 2001 to that in 2004?
Offer a terse response. 1.12. What is the ratio of the % of value added in manufacturing of Ireland in 2001 to that in 2004?
Ensure brevity in your answer.  1.07. What is the ratio of the % of value added in manufacturing in Singapore in 2001 to that in 2004?
Make the answer very short. 0.57. What is the ratio of the % of value added in manufacturing in Colombia in 2001 to that in 2005?
Keep it short and to the point. 1.19. What is the ratio of the % of value added in manufacturing in Ireland in 2001 to that in 2005?
Keep it short and to the point. 1.06. What is the ratio of the % of value added in manufacturing of Japan in 2001 to that in 2005?
Your answer should be compact. 1.01. What is the ratio of the % of value added in manufacturing of Singapore in 2001 to that in 2005?
Offer a very short reply. 0.65. What is the ratio of the % of value added in manufacturing of Colombia in 2001 to that in 2006?
Give a very brief answer. 1.23. What is the ratio of the % of value added in manufacturing in Ireland in 2001 to that in 2006?
Keep it short and to the point. 1.15. What is the ratio of the % of value added in manufacturing in Japan in 2001 to that in 2006?
Your response must be concise. 1.07. What is the ratio of the % of value added in manufacturing of Singapore in 2001 to that in 2006?
Your answer should be compact. 0.58. What is the ratio of the % of value added in manufacturing of Colombia in 2001 to that in 2007?
Keep it short and to the point. 1.3. What is the ratio of the % of value added in manufacturing of Ireland in 2001 to that in 2007?
Ensure brevity in your answer.  1.05. What is the ratio of the % of value added in manufacturing of Japan in 2001 to that in 2007?
Your answer should be compact. 1.09. What is the ratio of the % of value added in manufacturing in Singapore in 2001 to that in 2007?
Ensure brevity in your answer.  0.52. What is the ratio of the % of value added in manufacturing in Colombia in 2001 to that in 2008?
Make the answer very short. 1.18. What is the ratio of the % of value added in manufacturing in Ireland in 2001 to that in 2008?
Provide a succinct answer. 1.08. What is the ratio of the % of value added in manufacturing in Japan in 2001 to that in 2008?
Offer a very short reply. 1.06. What is the ratio of the % of value added in manufacturing of Singapore in 2001 to that in 2008?
Make the answer very short. 0.78. What is the ratio of the % of value added in manufacturing in Ireland in 2002 to that in 2003?
Your answer should be compact. 1.09. What is the ratio of the % of value added in manufacturing of Singapore in 2002 to that in 2003?
Your answer should be compact. 0.88. What is the ratio of the % of value added in manufacturing in Colombia in 2002 to that in 2004?
Ensure brevity in your answer.  1.11. What is the ratio of the % of value added in manufacturing of Ireland in 2002 to that in 2004?
Your response must be concise. 1.29. What is the ratio of the % of value added in manufacturing of Japan in 2002 to that in 2004?
Give a very brief answer. 1. What is the ratio of the % of value added in manufacturing in Singapore in 2002 to that in 2004?
Provide a short and direct response. 0.75. What is the ratio of the % of value added in manufacturing of Colombia in 2002 to that in 2005?
Provide a short and direct response. 1.18. What is the ratio of the % of value added in manufacturing in Ireland in 2002 to that in 2005?
Provide a succinct answer. 1.29. What is the ratio of the % of value added in manufacturing of Japan in 2002 to that in 2005?
Your answer should be very brief. 1.05. What is the ratio of the % of value added in manufacturing in Singapore in 2002 to that in 2005?
Keep it short and to the point. 0.85. What is the ratio of the % of value added in manufacturing in Colombia in 2002 to that in 2006?
Your answer should be compact. 1.22. What is the ratio of the % of value added in manufacturing in Ireland in 2002 to that in 2006?
Make the answer very short. 1.39. What is the ratio of the % of value added in manufacturing in Japan in 2002 to that in 2006?
Your answer should be compact. 1.11. What is the ratio of the % of value added in manufacturing of Singapore in 2002 to that in 2006?
Offer a very short reply. 0.75. What is the ratio of the % of value added in manufacturing in Colombia in 2002 to that in 2007?
Your response must be concise. 1.29. What is the ratio of the % of value added in manufacturing of Ireland in 2002 to that in 2007?
Make the answer very short. 1.27. What is the ratio of the % of value added in manufacturing in Japan in 2002 to that in 2007?
Provide a succinct answer. 1.14. What is the ratio of the % of value added in manufacturing of Singapore in 2002 to that in 2007?
Provide a succinct answer. 0.68. What is the ratio of the % of value added in manufacturing of Colombia in 2002 to that in 2008?
Keep it short and to the point. 1.17. What is the ratio of the % of value added in manufacturing in Ireland in 2002 to that in 2008?
Offer a terse response. 1.31. What is the ratio of the % of value added in manufacturing of Japan in 2002 to that in 2008?
Provide a short and direct response. 1.1. What is the ratio of the % of value added in manufacturing in Singapore in 2002 to that in 2008?
Your response must be concise. 1.02. What is the ratio of the % of value added in manufacturing in Colombia in 2003 to that in 2004?
Give a very brief answer. 1.11. What is the ratio of the % of value added in manufacturing of Ireland in 2003 to that in 2004?
Provide a short and direct response. 1.18. What is the ratio of the % of value added in manufacturing in Japan in 2003 to that in 2004?
Give a very brief answer. 1.01. What is the ratio of the % of value added in manufacturing in Singapore in 2003 to that in 2004?
Provide a succinct answer. 0.84. What is the ratio of the % of value added in manufacturing in Colombia in 2003 to that in 2005?
Offer a very short reply. 1.18. What is the ratio of the % of value added in manufacturing in Ireland in 2003 to that in 2005?
Your response must be concise. 1.18. What is the ratio of the % of value added in manufacturing in Japan in 2003 to that in 2005?
Your answer should be compact. 1.06. What is the ratio of the % of value added in manufacturing of Singapore in 2003 to that in 2005?
Provide a succinct answer. 0.96. What is the ratio of the % of value added in manufacturing in Colombia in 2003 to that in 2006?
Offer a terse response. 1.22. What is the ratio of the % of value added in manufacturing of Ireland in 2003 to that in 2006?
Your answer should be compact. 1.28. What is the ratio of the % of value added in manufacturing of Japan in 2003 to that in 2006?
Offer a very short reply. 1.11. What is the ratio of the % of value added in manufacturing in Singapore in 2003 to that in 2006?
Your answer should be very brief. 0.85. What is the ratio of the % of value added in manufacturing of Colombia in 2003 to that in 2007?
Provide a succinct answer. 1.28. What is the ratio of the % of value added in manufacturing of Ireland in 2003 to that in 2007?
Provide a short and direct response. 1.16. What is the ratio of the % of value added in manufacturing in Japan in 2003 to that in 2007?
Provide a succinct answer. 1.14. What is the ratio of the % of value added in manufacturing in Singapore in 2003 to that in 2007?
Provide a short and direct response. 0.77. What is the ratio of the % of value added in manufacturing in Ireland in 2003 to that in 2008?
Provide a short and direct response. 1.2. What is the ratio of the % of value added in manufacturing of Japan in 2003 to that in 2008?
Give a very brief answer. 1.11. What is the ratio of the % of value added in manufacturing in Singapore in 2003 to that in 2008?
Provide a succinct answer. 1.16. What is the ratio of the % of value added in manufacturing in Japan in 2004 to that in 2005?
Your response must be concise. 1.05. What is the ratio of the % of value added in manufacturing in Singapore in 2004 to that in 2005?
Give a very brief answer. 1.14. What is the ratio of the % of value added in manufacturing of Colombia in 2004 to that in 2006?
Your answer should be very brief. 1.1. What is the ratio of the % of value added in manufacturing in Ireland in 2004 to that in 2006?
Your response must be concise. 1.08. What is the ratio of the % of value added in manufacturing of Japan in 2004 to that in 2006?
Keep it short and to the point. 1.1. What is the ratio of the % of value added in manufacturing of Singapore in 2004 to that in 2006?
Give a very brief answer. 1.01. What is the ratio of the % of value added in manufacturing of Colombia in 2004 to that in 2007?
Your answer should be very brief. 1.16. What is the ratio of the % of value added in manufacturing of Japan in 2004 to that in 2007?
Provide a succinct answer. 1.13. What is the ratio of the % of value added in manufacturing of Singapore in 2004 to that in 2007?
Give a very brief answer. 0.91. What is the ratio of the % of value added in manufacturing in Colombia in 2004 to that in 2008?
Make the answer very short. 1.05. What is the ratio of the % of value added in manufacturing in Ireland in 2004 to that in 2008?
Your answer should be compact. 1.02. What is the ratio of the % of value added in manufacturing in Japan in 2004 to that in 2008?
Your response must be concise. 1.1. What is the ratio of the % of value added in manufacturing of Singapore in 2004 to that in 2008?
Provide a short and direct response. 1.37. What is the ratio of the % of value added in manufacturing in Colombia in 2005 to that in 2006?
Provide a short and direct response. 1.03. What is the ratio of the % of value added in manufacturing of Ireland in 2005 to that in 2006?
Provide a succinct answer. 1.08. What is the ratio of the % of value added in manufacturing in Japan in 2005 to that in 2006?
Provide a succinct answer. 1.05. What is the ratio of the % of value added in manufacturing of Singapore in 2005 to that in 2006?
Your response must be concise. 0.89. What is the ratio of the % of value added in manufacturing in Colombia in 2005 to that in 2007?
Your response must be concise. 1.09. What is the ratio of the % of value added in manufacturing of Ireland in 2005 to that in 2007?
Offer a very short reply. 0.99. What is the ratio of the % of value added in manufacturing in Japan in 2005 to that in 2007?
Ensure brevity in your answer.  1.08. What is the ratio of the % of value added in manufacturing in Singapore in 2005 to that in 2007?
Offer a terse response. 0.8. What is the ratio of the % of value added in manufacturing in Colombia in 2005 to that in 2008?
Your response must be concise. 0.99. What is the ratio of the % of value added in manufacturing in Ireland in 2005 to that in 2008?
Provide a succinct answer. 1.02. What is the ratio of the % of value added in manufacturing in Japan in 2005 to that in 2008?
Give a very brief answer. 1.05. What is the ratio of the % of value added in manufacturing in Singapore in 2005 to that in 2008?
Your answer should be compact. 1.2. What is the ratio of the % of value added in manufacturing of Colombia in 2006 to that in 2007?
Keep it short and to the point. 1.06. What is the ratio of the % of value added in manufacturing in Ireland in 2006 to that in 2007?
Keep it short and to the point. 0.91. What is the ratio of the % of value added in manufacturing in Japan in 2006 to that in 2007?
Provide a succinct answer. 1.03. What is the ratio of the % of value added in manufacturing of Singapore in 2006 to that in 2007?
Provide a succinct answer. 0.9. What is the ratio of the % of value added in manufacturing of Colombia in 2006 to that in 2008?
Your answer should be compact. 0.96. What is the ratio of the % of value added in manufacturing in Ireland in 2006 to that in 2008?
Ensure brevity in your answer.  0.94. What is the ratio of the % of value added in manufacturing in Japan in 2006 to that in 2008?
Offer a very short reply. 1. What is the ratio of the % of value added in manufacturing in Singapore in 2006 to that in 2008?
Offer a terse response. 1.36. What is the ratio of the % of value added in manufacturing of Colombia in 2007 to that in 2008?
Give a very brief answer. 0.91. What is the ratio of the % of value added in manufacturing in Ireland in 2007 to that in 2008?
Make the answer very short. 1.03. What is the ratio of the % of value added in manufacturing of Japan in 2007 to that in 2008?
Offer a very short reply. 0.97. What is the ratio of the % of value added in manufacturing in Singapore in 2007 to that in 2008?
Your answer should be very brief. 1.5. What is the difference between the highest and the second highest % of value added in manufacturing of Colombia?
Your answer should be very brief. 0.15. What is the difference between the highest and the second highest % of value added in manufacturing in Ireland?
Provide a short and direct response. 3.81. What is the difference between the highest and the second highest % of value added in manufacturing of Japan?
Give a very brief answer. 0.06. What is the difference between the highest and the second highest % of value added in manufacturing in Singapore?
Offer a very short reply. 2.75. What is the difference between the highest and the lowest % of value added in manufacturing of Colombia?
Make the answer very short. 3.61. What is the difference between the highest and the lowest % of value added in manufacturing in Ireland?
Provide a short and direct response. 12.74. What is the difference between the highest and the lowest % of value added in manufacturing of Japan?
Make the answer very short. 1.43. What is the difference between the highest and the lowest % of value added in manufacturing of Singapore?
Offer a very short reply. 15.11. 